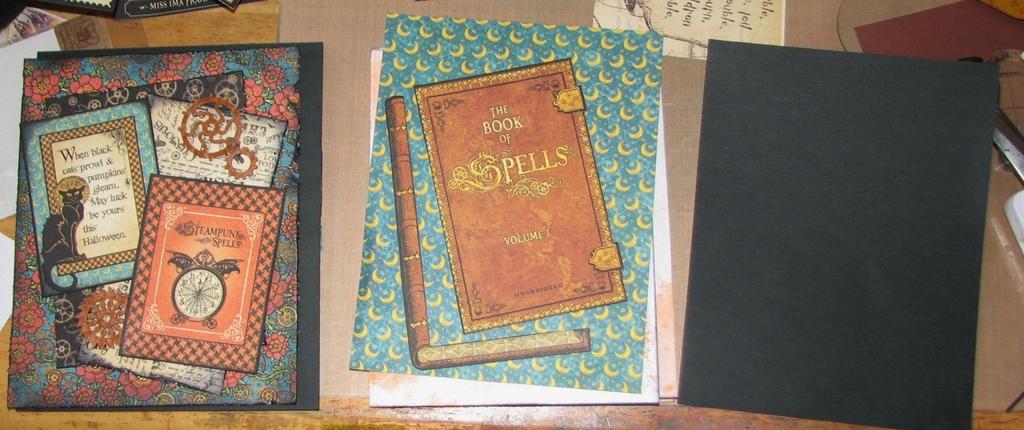What kind of book is this?
Provide a succinct answer. Book of spells. The book of spells is volume what?
Provide a short and direct response. 1. 